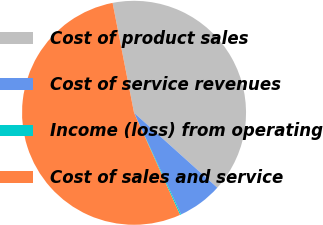Convert chart to OTSL. <chart><loc_0><loc_0><loc_500><loc_500><pie_chart><fcel>Cost of product sales<fcel>Cost of service revenues<fcel>Income (loss) from operating<fcel>Cost of sales and service<nl><fcel>39.73%<fcel>6.44%<fcel>0.17%<fcel>53.66%<nl></chart> 